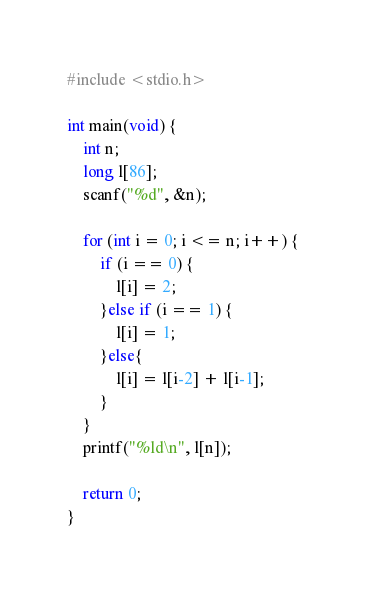<code> <loc_0><loc_0><loc_500><loc_500><_C_>#include <stdio.h>
 
int main(void) {
	int n;
	long l[86];
	scanf("%d", &n);
	
	for (int i = 0; i <= n; i++) {
		if (i == 0) {
			l[i] = 2;
		}else if (i == 1) {
			l[i] = 1;
		}else{
			l[i] = l[i-2] + l[i-1];
		}
	}
	printf("%ld\n", l[n]);
	
	return 0;
}</code> 